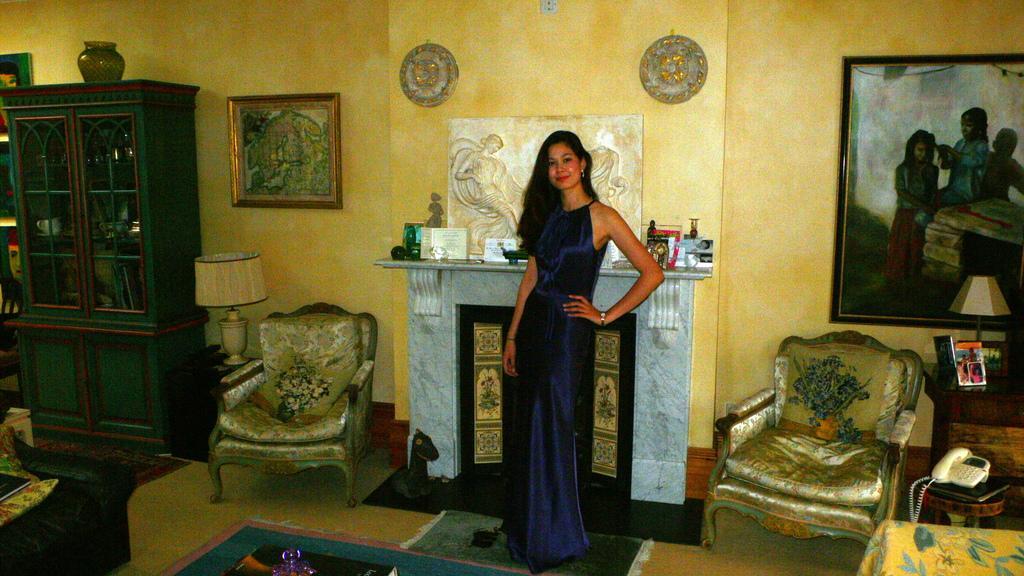Describe this image in one or two sentences. In this picture we can see a woman standing on the floor. There are chairs. And this is a cupboard. Here we can see a lamp. On the background there is a wall and these are the frames. And this is floor. 